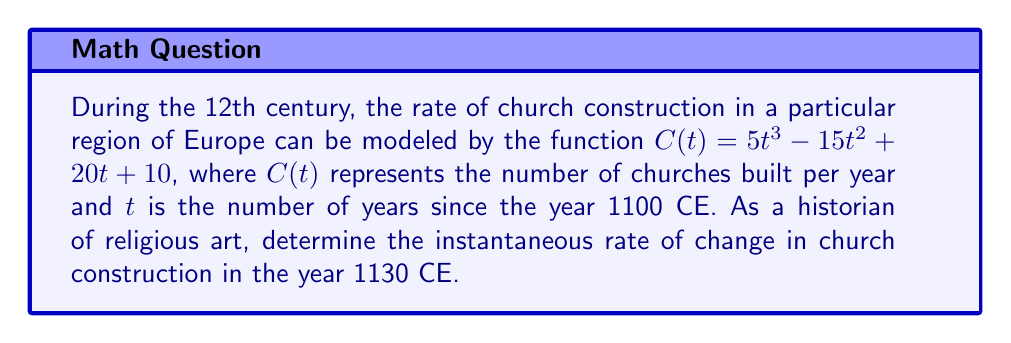Can you answer this question? To solve this problem, we need to follow these steps:

1) First, we need to find the derivative of the given function $C(t)$. This will give us the rate of change function.

   $$\frac{d}{dt}C(t) = \frac{d}{dt}(5t^3 - 15t^2 + 20t + 10)$$
   $$C'(t) = 15t^2 - 30t + 20$$

2) Now, we need to determine the value of $t$ that corresponds to the year 1130 CE. Since $t$ is the number of years since 1100 CE:

   1130 - 1100 = 30 years

3) We can now substitute $t = 30$ into our derivative function:

   $$C'(30) = 15(30)^2 - 30(30) + 20$$
   $$= 15(900) - 900 + 20$$
   $$= 13500 - 900 + 20$$
   $$= 12620$$

4) Interpret the result: The instantaneous rate of change in church construction in the year 1130 CE was 12620 churches per year.

This rapid growth rate aligns with the historical context of the 12th century, which saw a significant increase in church construction across Europe, particularly in the Romanesque and early Gothic styles.
Answer: 12620 churches per year 